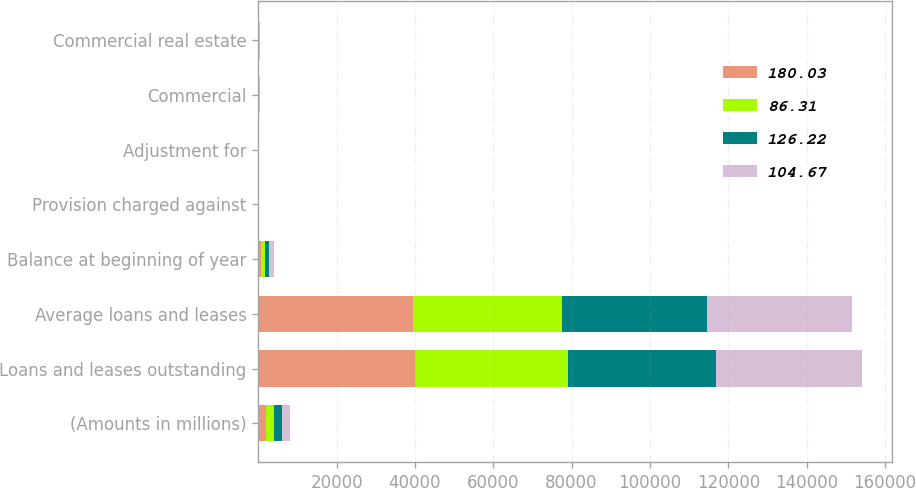Convert chart to OTSL. <chart><loc_0><loc_0><loc_500><loc_500><stacked_bar_chart><ecel><fcel>(Amounts in millions)<fcel>Loans and leases outstanding<fcel>Average loans and leases<fcel>Balance at beginning of year<fcel>Provision charged against<fcel>Adjustment for<fcel>Commercial<fcel>Commercial real estate<nl><fcel>180.03<fcel>2014<fcel>40064<fcel>39523<fcel>746<fcel>98<fcel>1<fcel>77<fcel>15<nl><fcel>86.31<fcel>2013<fcel>39043<fcel>38107<fcel>896<fcel>87<fcel>11<fcel>76<fcel>26<nl><fcel>126.22<fcel>2012<fcel>37665<fcel>37037<fcel>1052<fcel>14<fcel>15<fcel>121<fcel>85<nl><fcel>104.67<fcel>2011<fcel>37258<fcel>36897<fcel>1442<fcel>75<fcel>9<fcel>241<fcel>229<nl></chart> 